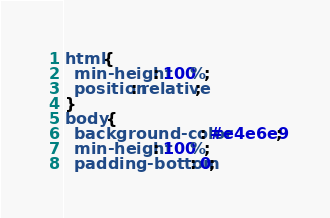<code> <loc_0><loc_0><loc_500><loc_500><_CSS_>html {
  min-height: 100%;
  position: relative;
}
body {
  background-color: #e4e6e9;
  min-height: 100%;
  padding-bottom: 0;</code> 